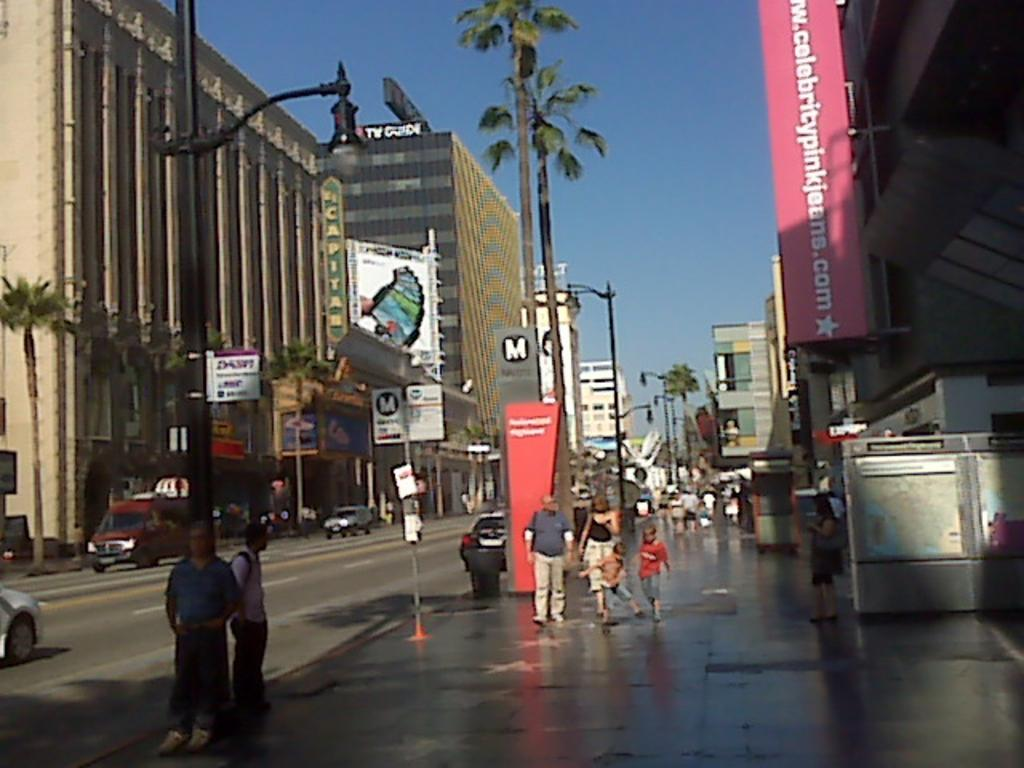<image>
Describe the image concisely. an exterior shot of a city with a sign for www.celebritypinkjeans.com above the wet sidewalk 